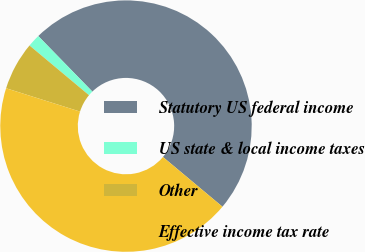Convert chart to OTSL. <chart><loc_0><loc_0><loc_500><loc_500><pie_chart><fcel>Statutory US federal income<fcel>US state & local income taxes<fcel>Other<fcel>Effective income tax rate<nl><fcel>48.37%<fcel>1.63%<fcel>6.21%<fcel>43.79%<nl></chart> 